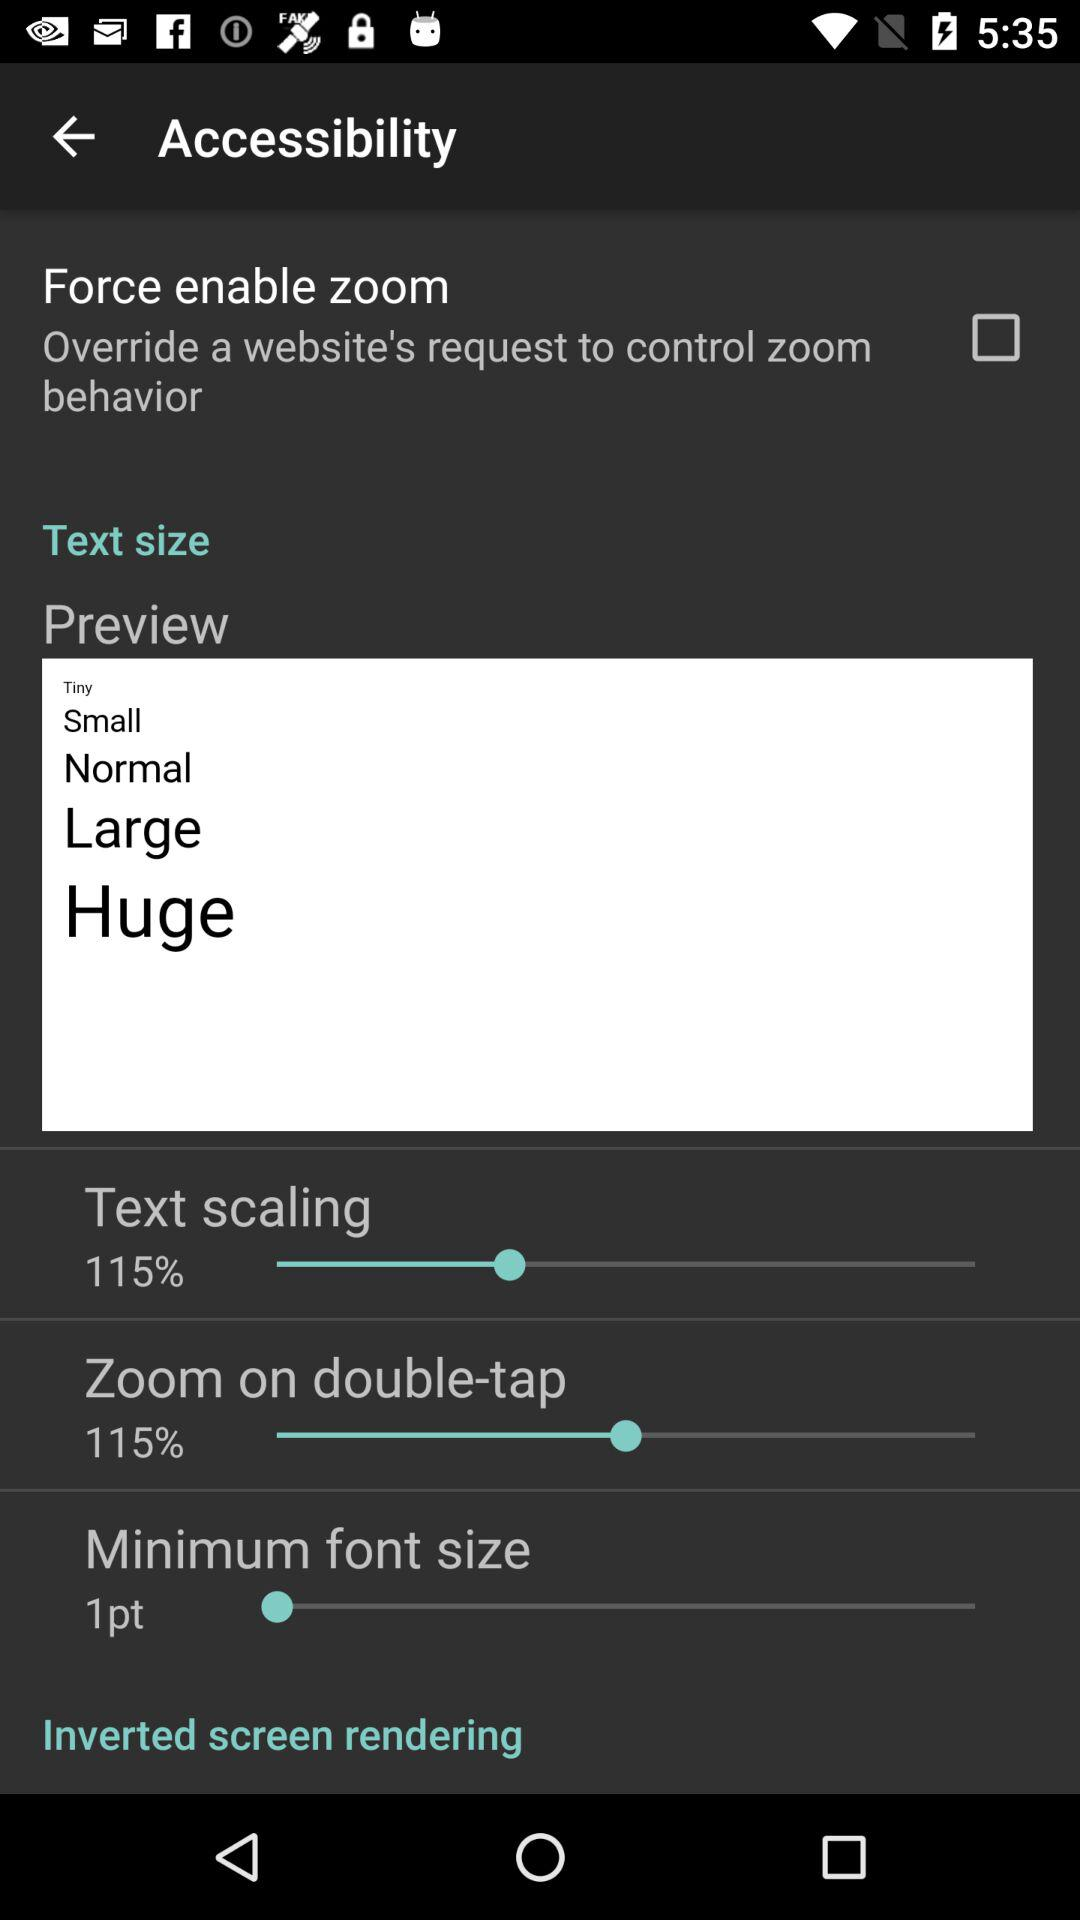What is the minimum font size? The minimum font size is 1 point. 